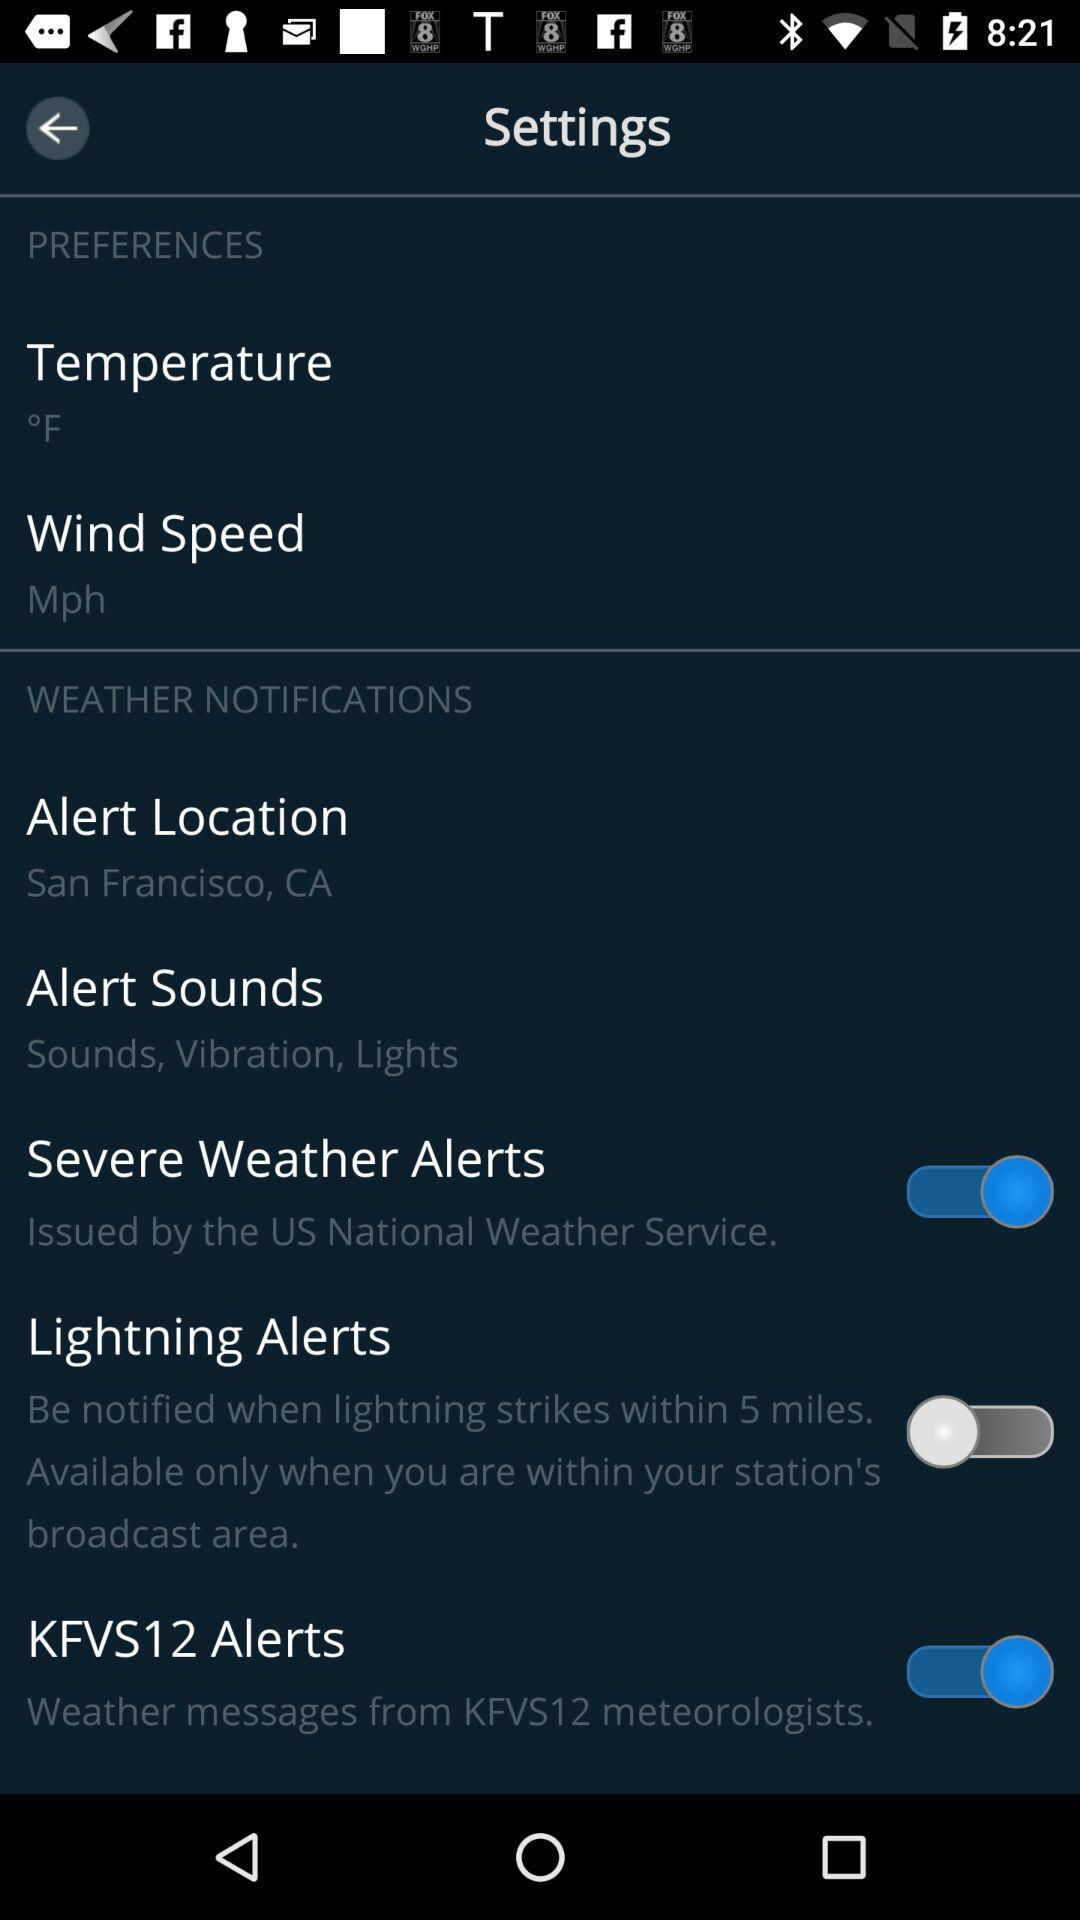What is the status of "Lightning Alerts"? The status is "off". 